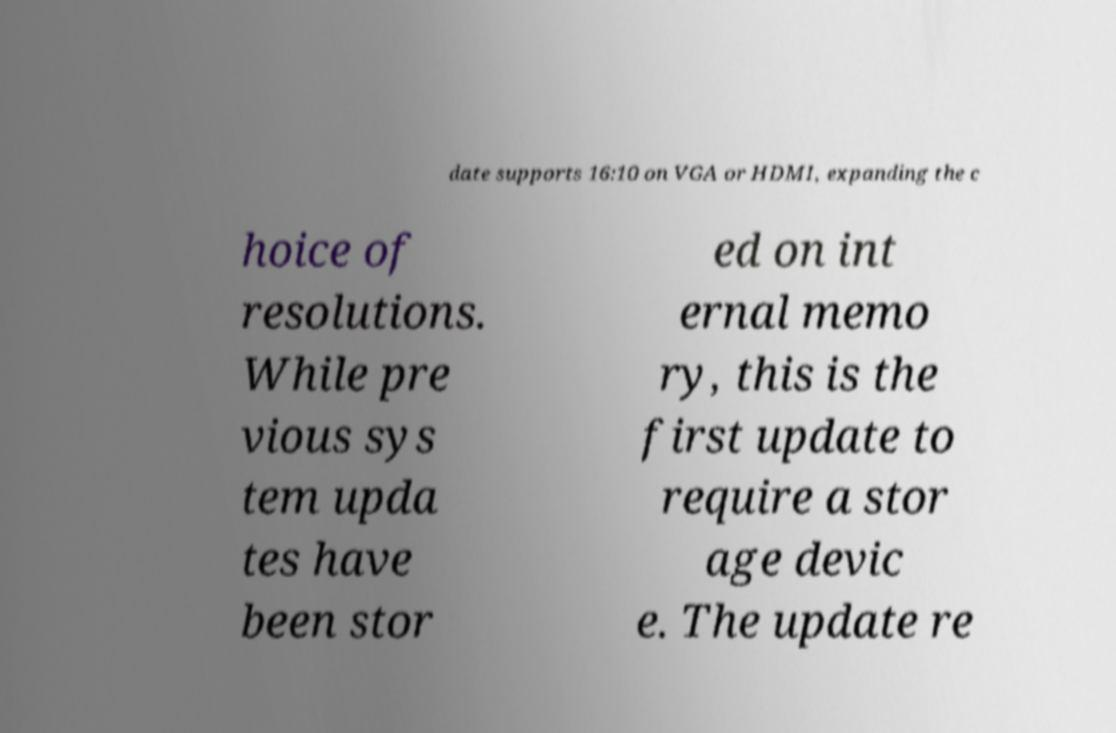Please identify and transcribe the text found in this image. date supports 16:10 on VGA or HDMI, expanding the c hoice of resolutions. While pre vious sys tem upda tes have been stor ed on int ernal memo ry, this is the first update to require a stor age devic e. The update re 